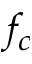<formula> <loc_0><loc_0><loc_500><loc_500>f _ { c }</formula> 